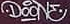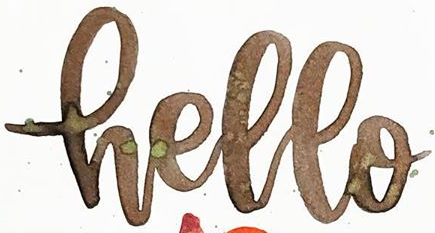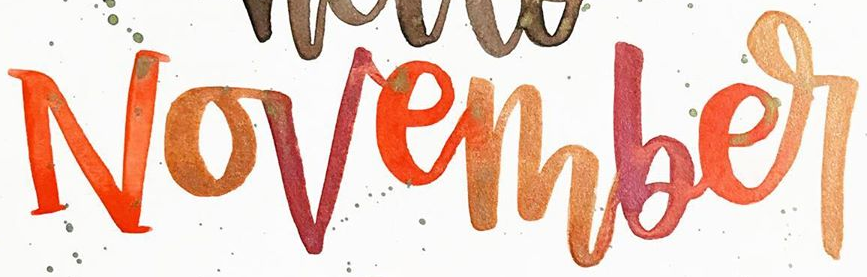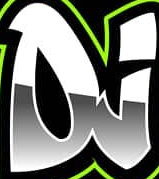What text is displayed in these images sequentially, separated by a semicolon? DOONE; Hello; November; DJ 